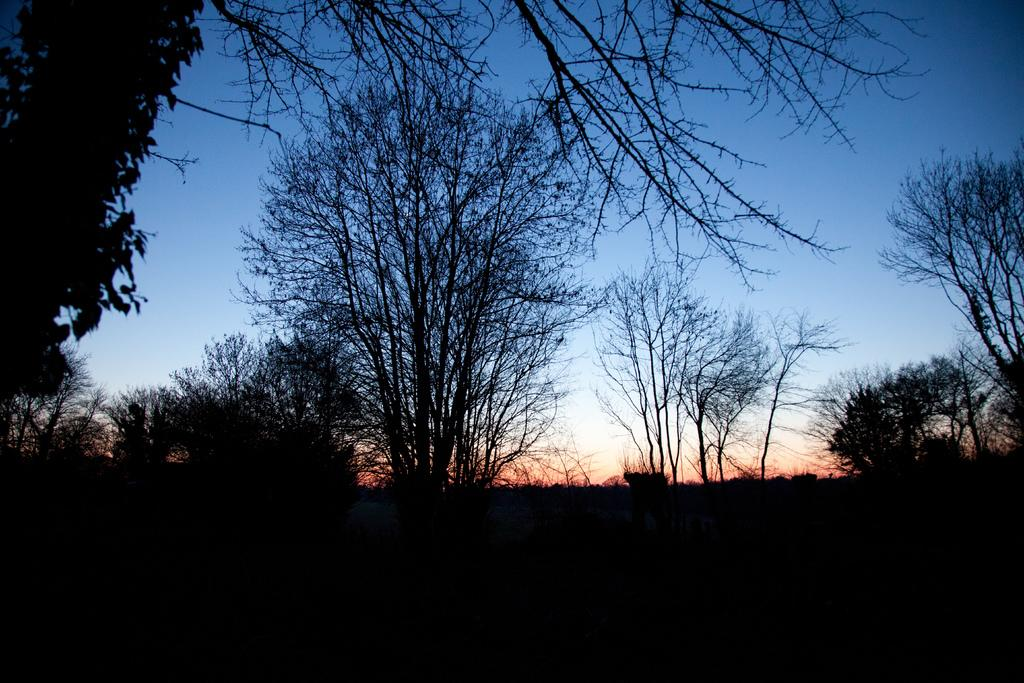What type of vegetation can be seen in the image? There are trees in the image. What is visible at the top of the image? The sky is visible at the top of the image. What type of flesh can be seen on the trees in the image? There is no flesh present on the trees in the image; they are made of wood and leaves. What kind of rock formation is visible in the image? There is no rock formation present in the image; it features trees and the sky. 